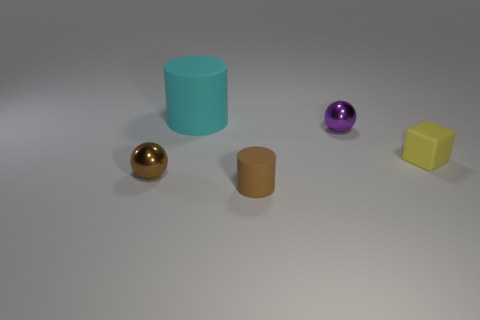Are there any other things that are the same material as the small yellow cube?
Your answer should be very brief. Yes. There is a matte thing in front of the tiny yellow object; is it the same color as the sphere that is in front of the small block?
Offer a very short reply. Yes. The tiny ball that is in front of the small matte object that is behind the matte cylinder in front of the yellow cube is made of what material?
Your response must be concise. Metal. Are there more tiny brown metal spheres than metal spheres?
Give a very brief answer. No. Is there any other thing that has the same color as the tiny rubber cylinder?
Your answer should be very brief. Yes. There is a cyan thing that is made of the same material as the small cube; what size is it?
Your answer should be very brief. Large. What is the material of the small brown cylinder?
Make the answer very short. Rubber. What number of brown metallic balls have the same size as the purple sphere?
Keep it short and to the point. 1. Is there another thing that has the same shape as the cyan thing?
Your answer should be very brief. Yes. There is another matte thing that is the same size as the yellow thing; what color is it?
Your response must be concise. Brown. 